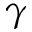Convert formula to latex. <formula><loc_0><loc_0><loc_500><loc_500>\gamma</formula> 